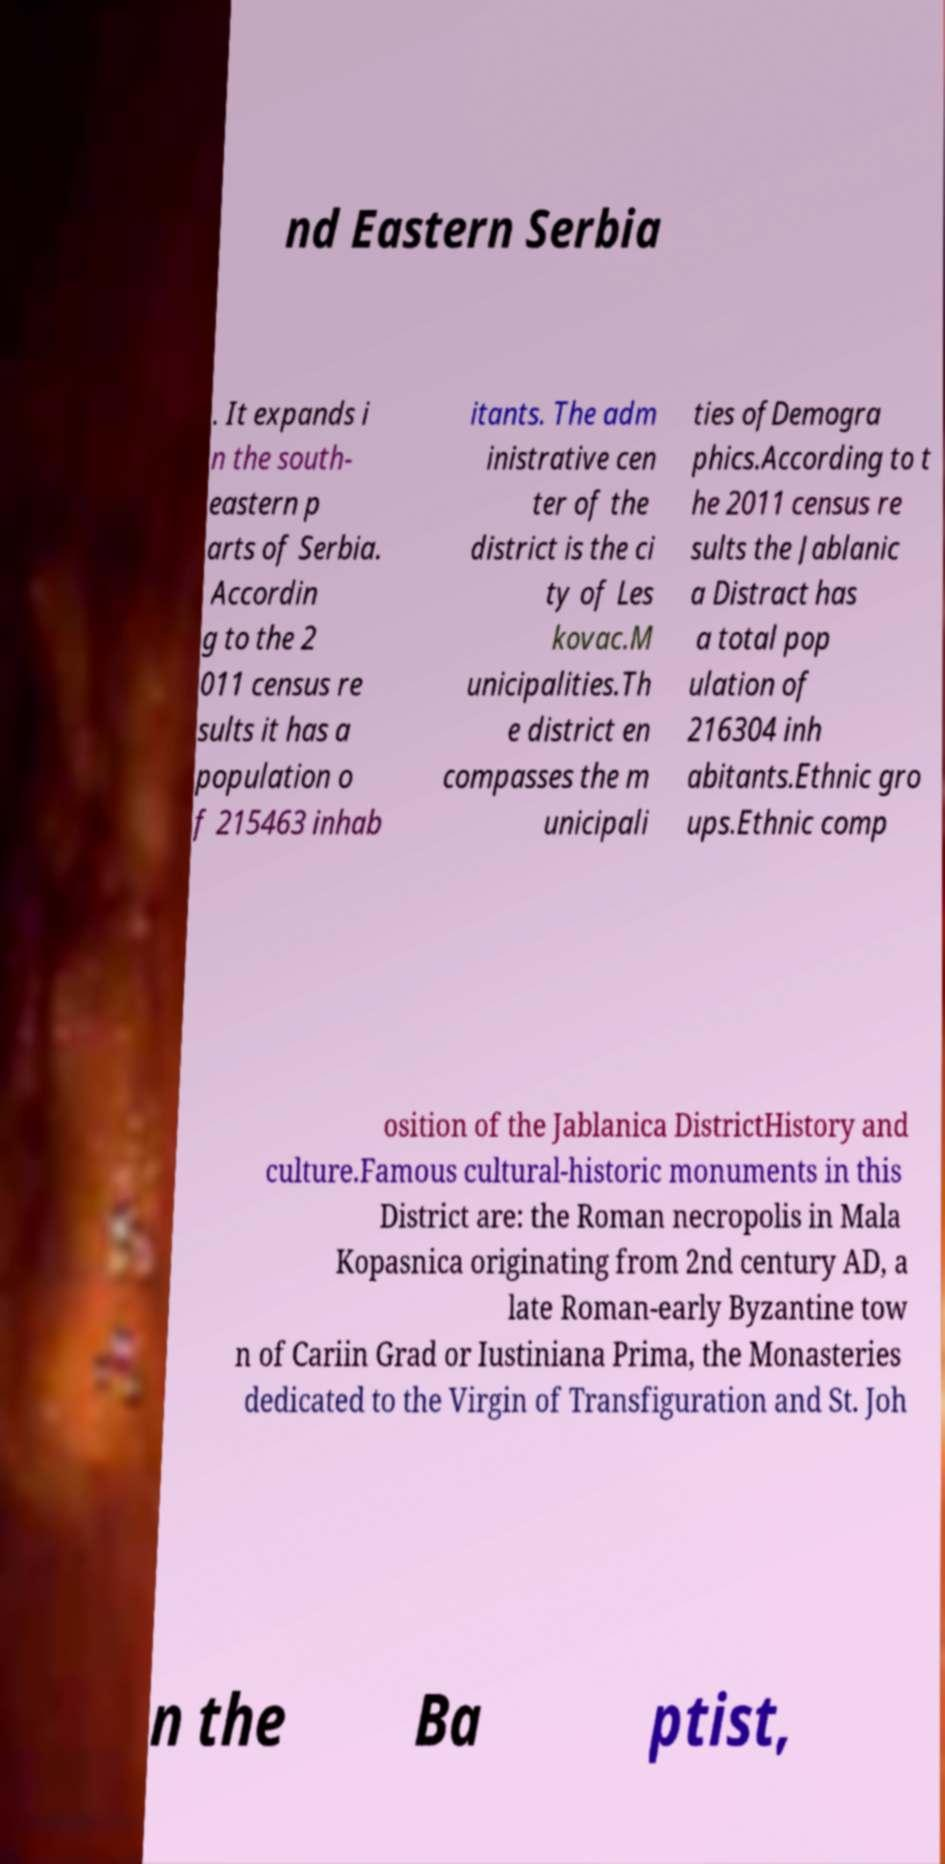Could you extract and type out the text from this image? nd Eastern Serbia . It expands i n the south- eastern p arts of Serbia. Accordin g to the 2 011 census re sults it has a population o f 215463 inhab itants. The adm inistrative cen ter of the district is the ci ty of Les kovac.M unicipalities.Th e district en compasses the m unicipali ties ofDemogra phics.According to t he 2011 census re sults the Jablanic a Distract has a total pop ulation of 216304 inh abitants.Ethnic gro ups.Ethnic comp osition of the Jablanica DistrictHistory and culture.Famous cultural-historic monuments in this District are: the Roman necropolis in Mala Kopasnica originating from 2nd century AD, a late Roman-early Byzantine tow n of Cariin Grad or Iustiniana Prima, the Monasteries dedicated to the Virgin of Transfiguration and St. Joh n the Ba ptist, 